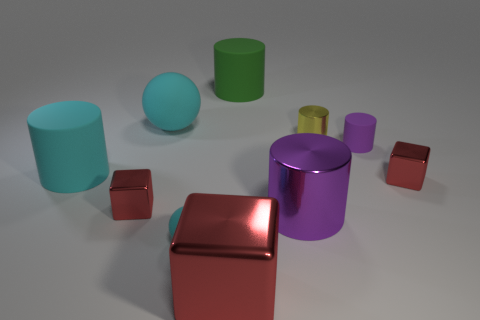Subtract all green cylinders. How many cylinders are left? 4 Subtract all purple metal cylinders. How many cylinders are left? 4 Subtract all gray cylinders. Subtract all red blocks. How many cylinders are left? 5 Subtract all spheres. How many objects are left? 8 Subtract all rubber objects. Subtract all large shiny blocks. How many objects are left? 4 Add 7 rubber cylinders. How many rubber cylinders are left? 10 Add 3 small cyan objects. How many small cyan objects exist? 4 Subtract 0 gray balls. How many objects are left? 10 